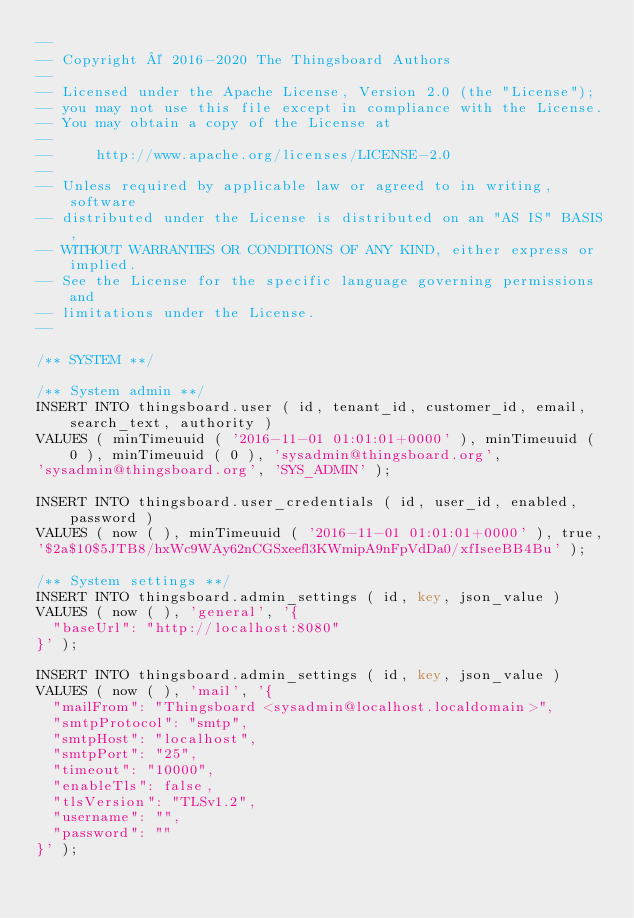Convert code to text. <code><loc_0><loc_0><loc_500><loc_500><_SQL_>--
-- Copyright © 2016-2020 The Thingsboard Authors
--
-- Licensed under the Apache License, Version 2.0 (the "License");
-- you may not use this file except in compliance with the License.
-- You may obtain a copy of the License at
--
--     http://www.apache.org/licenses/LICENSE-2.0
--
-- Unless required by applicable law or agreed to in writing, software
-- distributed under the License is distributed on an "AS IS" BASIS,
-- WITHOUT WARRANTIES OR CONDITIONS OF ANY KIND, either express or implied.
-- See the License for the specific language governing permissions and
-- limitations under the License.
--

/** SYSTEM **/

/** System admin **/
INSERT INTO thingsboard.user ( id, tenant_id, customer_id, email, search_text, authority )
VALUES ( minTimeuuid ( '2016-11-01 01:01:01+0000' ), minTimeuuid ( 0 ), minTimeuuid ( 0 ), 'sysadmin@thingsboard.org',
'sysadmin@thingsboard.org', 'SYS_ADMIN' );

INSERT INTO thingsboard.user_credentials ( id, user_id, enabled, password )
VALUES ( now ( ), minTimeuuid ( '2016-11-01 01:01:01+0000' ), true,
'$2a$10$5JTB8/hxWc9WAy62nCGSxeefl3KWmipA9nFpVdDa0/xfIseeBB4Bu' );

/** System settings **/
INSERT INTO thingsboard.admin_settings ( id, key, json_value )
VALUES ( now ( ), 'general', '{
	"baseUrl": "http://localhost:8080"
}' );

INSERT INTO thingsboard.admin_settings ( id, key, json_value )
VALUES ( now ( ), 'mail', '{
	"mailFrom": "Thingsboard <sysadmin@localhost.localdomain>",
	"smtpProtocol": "smtp",
	"smtpHost": "localhost",
	"smtpPort": "25",
	"timeout": "10000",
	"enableTls": false,
	"tlsVersion": "TLSv1.2",
	"username": "",
	"password": ""
}' );</code> 